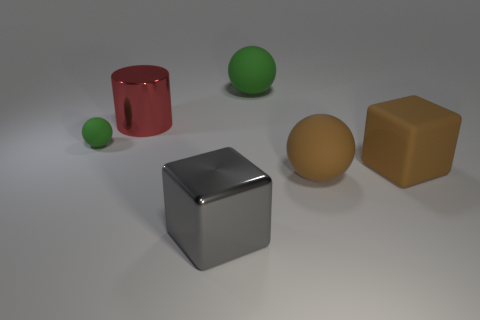Add 2 rubber spheres. How many objects exist? 8 Subtract all blocks. How many objects are left? 4 Add 1 large red metallic objects. How many large red metallic objects are left? 2 Add 4 purple cylinders. How many purple cylinders exist? 4 Subtract 0 green cylinders. How many objects are left? 6 Subtract all green rubber blocks. Subtract all small matte balls. How many objects are left? 5 